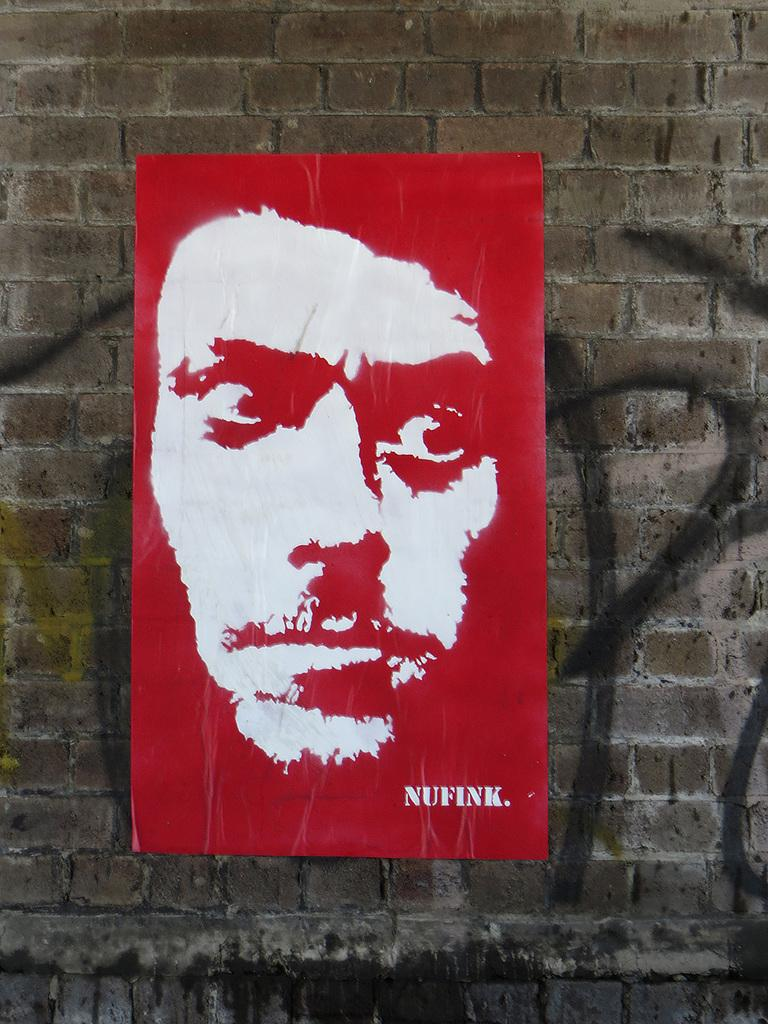<image>
Create a compact narrative representing the image presented. A red banner features a white portrait of someone's face and is labelled "NUFINK." 